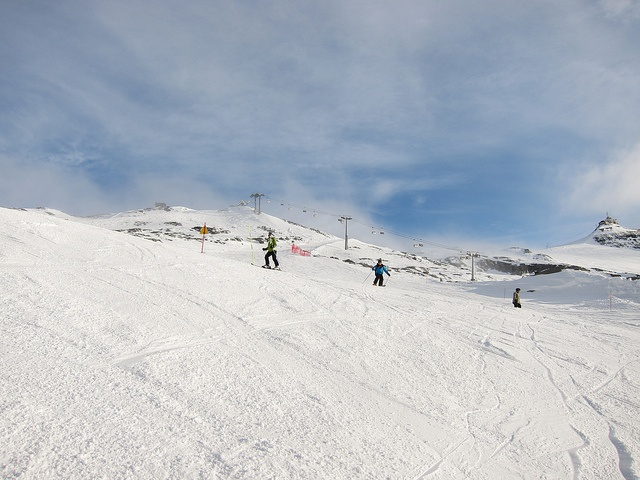Describe the objects in this image and their specific colors. I can see people in gray, lightgray, black, and darkgray tones, people in gray, black, lightgray, and darkgray tones, people in gray, black, darkgray, and tan tones, and skis in gray, lightgray, darkgray, and black tones in this image. 